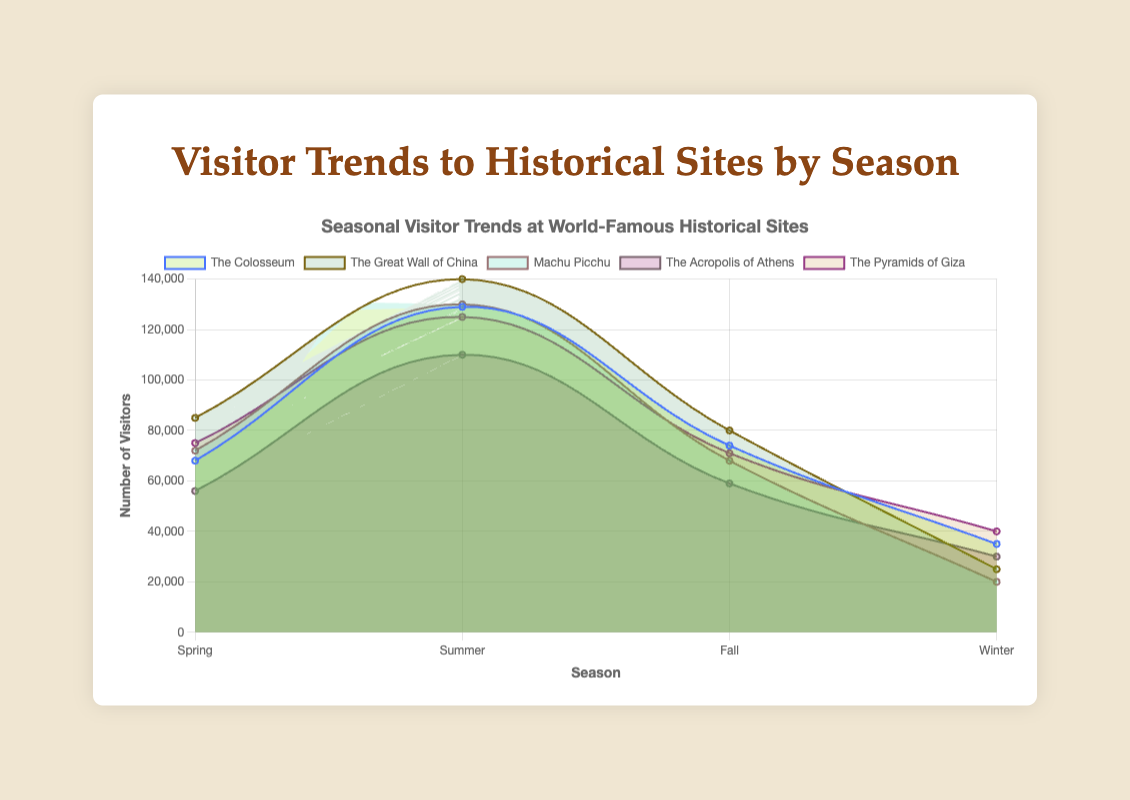What is the title of the chart? The title is located at the top of the chart, displayed prominently to describe what the chart is about.
Answer: Visitor Trends to Historical Sites by Season Which historical site has the most visitors in Summer? Look at the data points on the chart for each site during Summer. Identify which line reaches the highest value during this season.
Answer: The Great Wall of China What is the general trend in visitor numbers for The Acropolis of Athens? Observe the data points for The Acropolis of Athens across all seasons to note any patterns.
Answer: Spring: 56000, Summer: 110000, Fall: 59000, Winter: 30000. Visitor numbers peak in Summer and are lowest in Winter Which season has the lowest total visitors across all sites? Add up the visitor numbers for all sites in each season and compare the totals.
Answer: Winter How many visitors does Machu Picchu have in Fall compared to Winter? Look at the data points for Machu Picchu in Fall and Winter, then note the visitor numbers.
Answer: Fall: 68,000, Winter: 20,000. Machu Picchu has 48,000 more visitors in Fall than Winter What is the difference in number of visitors between The Colosseum and The Great Wall of China in Winter? Find the visitor numbers for both sites in Winter and subtract the smaller number from the larger one.
Answer: The Colosseum: 35,000, The Great Wall of China: 25,000. The difference is 10,000 Which site shows the least variation in visitor numbers throughout the year? Check the range (difference between the maximum and minimum values) for each site's visitor numbers across all seasons. Identify the site with the smallest range.
Answer: The Acropolis of Athens What percentage of The Pyramids of Giza's yearly visitors come during Summer? First, add up the total number of visitors for The Pyramids of Giza across all seasons. Then, divide the number of Summer visitors by this total and multiply by 100.
Answer: (125,000 / (75,000 + 125,000 + 71,000 + 40,000)) * 100 = 125,000 / 311,000 * 100 ≈ 40.2% Which season does The Colosseum have its second highest visitors? Look at The Colosseum's visitor numbers for each season and identify the second highest.
Answer: Spring What is the total number of visitors for all sites in Spring? Sum the visitor numbers for all sites during Spring.
Answer: 68,000 + 85,000 + 72,000 + 56,000 + 75,000 = 356,000 